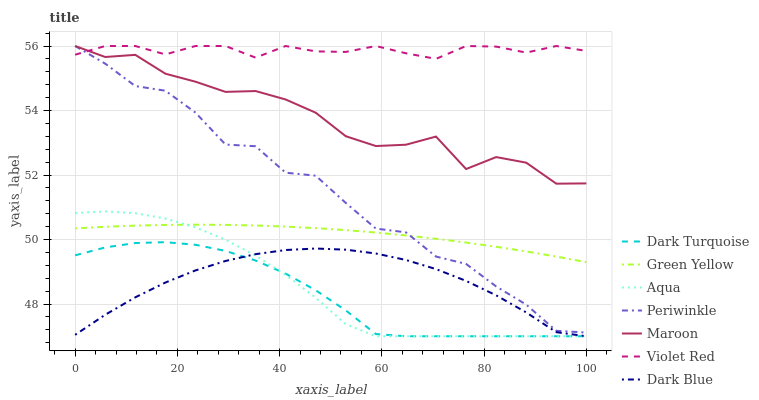Does Dark Turquoise have the minimum area under the curve?
Answer yes or no. Yes. Does Violet Red have the maximum area under the curve?
Answer yes or no. Yes. Does Aqua have the minimum area under the curve?
Answer yes or no. No. Does Aqua have the maximum area under the curve?
Answer yes or no. No. Is Green Yellow the smoothest?
Answer yes or no. Yes. Is Periwinkle the roughest?
Answer yes or no. Yes. Is Dark Turquoise the smoothest?
Answer yes or no. No. Is Dark Turquoise the roughest?
Answer yes or no. No. Does Dark Turquoise have the lowest value?
Answer yes or no. Yes. Does Maroon have the lowest value?
Answer yes or no. No. Does Periwinkle have the highest value?
Answer yes or no. Yes. Does Dark Turquoise have the highest value?
Answer yes or no. No. Is Dark Turquoise less than Violet Red?
Answer yes or no. Yes. Is Violet Red greater than Dark Turquoise?
Answer yes or no. Yes. Does Periwinkle intersect Maroon?
Answer yes or no. Yes. Is Periwinkle less than Maroon?
Answer yes or no. No. Is Periwinkle greater than Maroon?
Answer yes or no. No. Does Dark Turquoise intersect Violet Red?
Answer yes or no. No. 